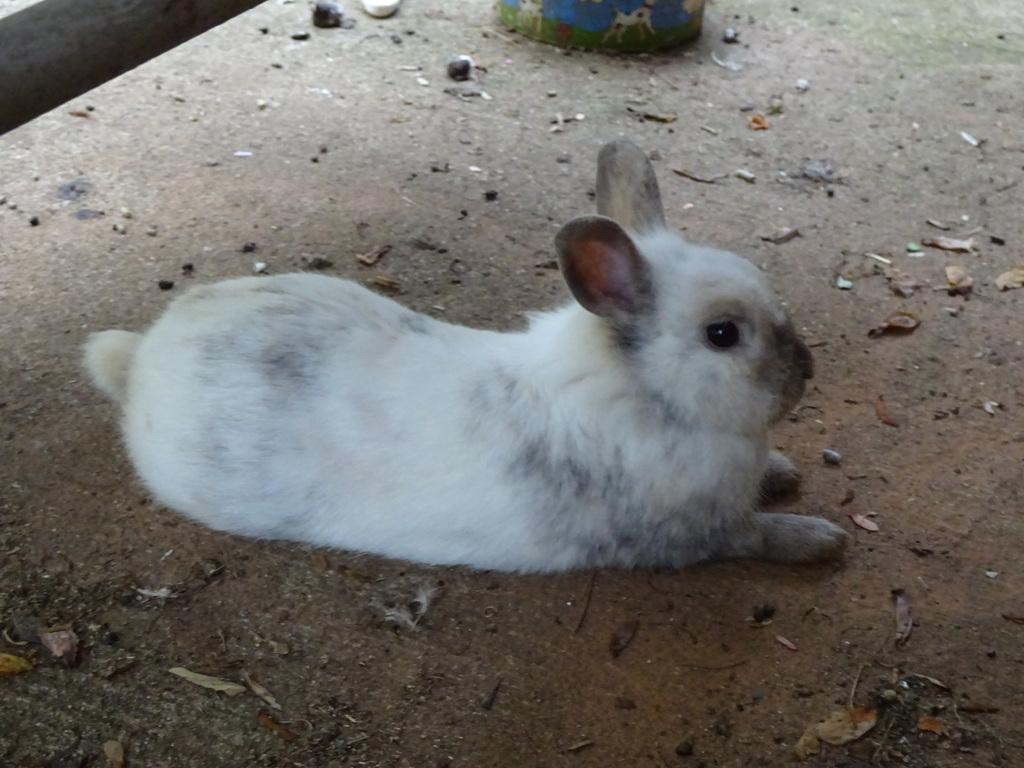What is the main subject in the middle of the picture? There is a white rabbit in the middle of the picture. What can be seen at the bottom of the image? Dry leaves and small stones are visible at the bottom of the image. What color is the object at the top of the image? The object at the top of the image is in blue color. How does the fly interact with the bait in the image? There is no fly or bait present in the image. What type of umbrella is being used by the rabbit in the image? There is no umbrella present in the image, and the rabbit is not using any umbrella. 